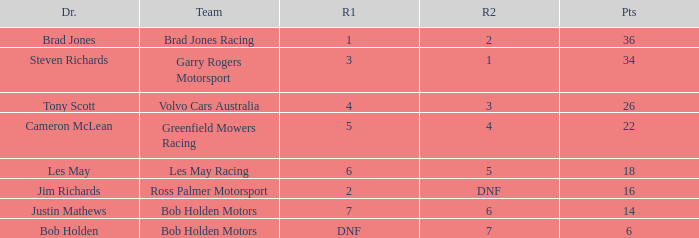Which team received 4 in race 1? Volvo Cars Australia. 